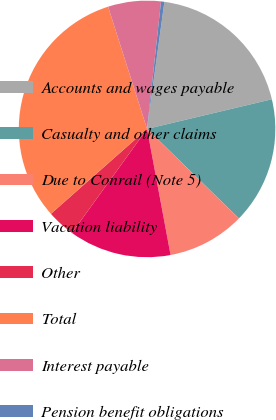Convert chart to OTSL. <chart><loc_0><loc_0><loc_500><loc_500><pie_chart><fcel>Accounts and wages payable<fcel>Casualty and other claims<fcel>Due to Conrail (Note 5)<fcel>Vacation liability<fcel>Other<fcel>Total<fcel>Interest payable<fcel>Pension benefit obligations<nl><fcel>19.13%<fcel>16.01%<fcel>9.77%<fcel>12.89%<fcel>3.53%<fcel>31.6%<fcel>6.65%<fcel>0.42%<nl></chart> 